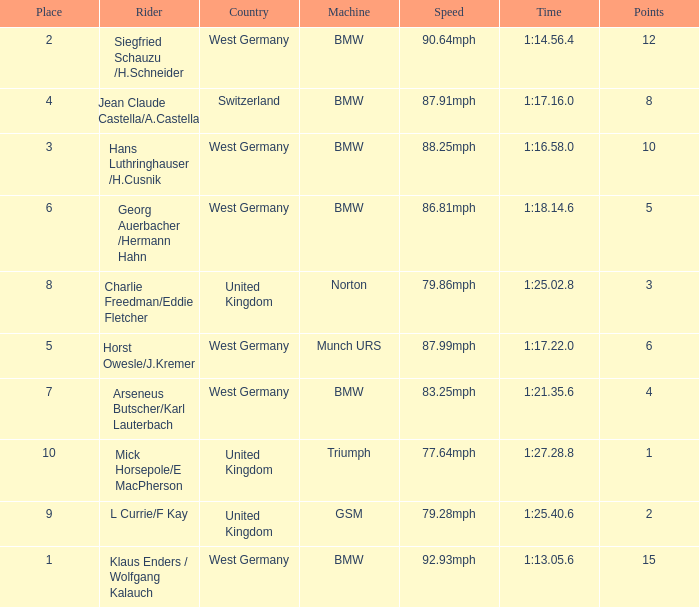Which places have points larger than 10? None. 